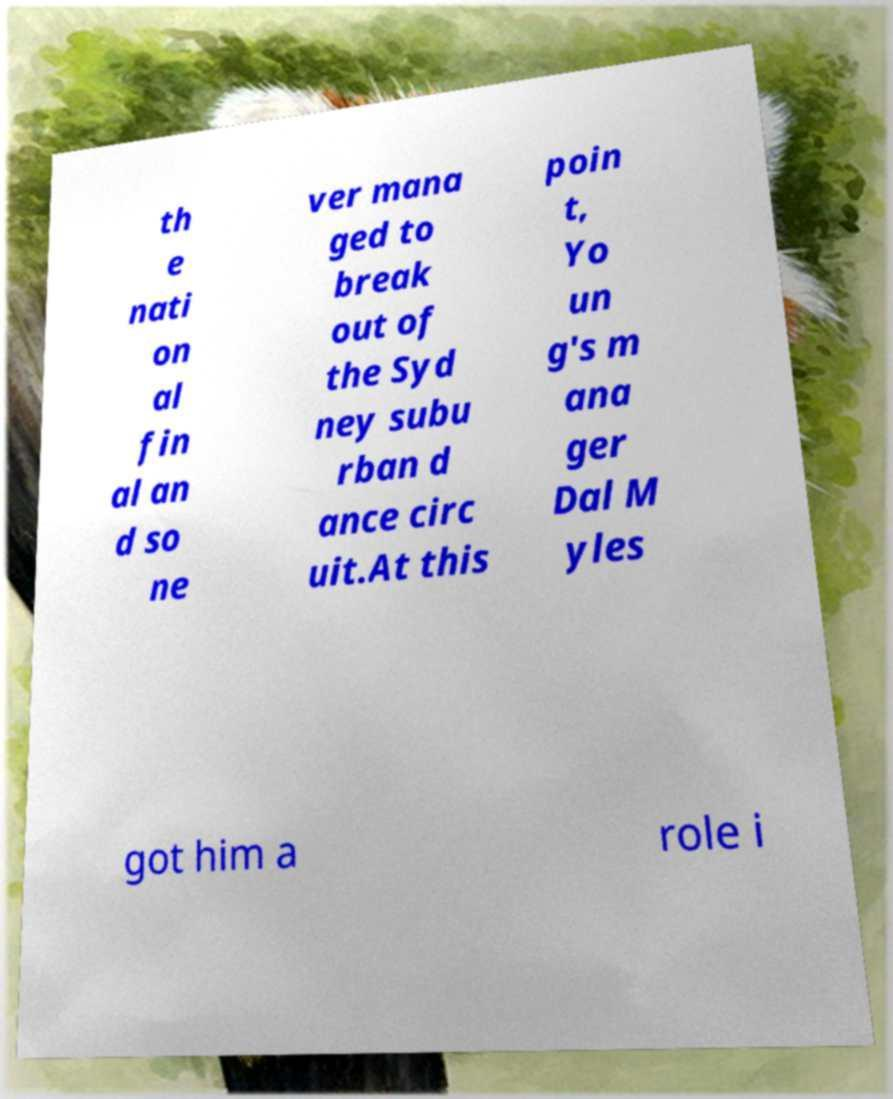Could you extract and type out the text from this image? th e nati on al fin al an d so ne ver mana ged to break out of the Syd ney subu rban d ance circ uit.At this poin t, Yo un g's m ana ger Dal M yles got him a role i 